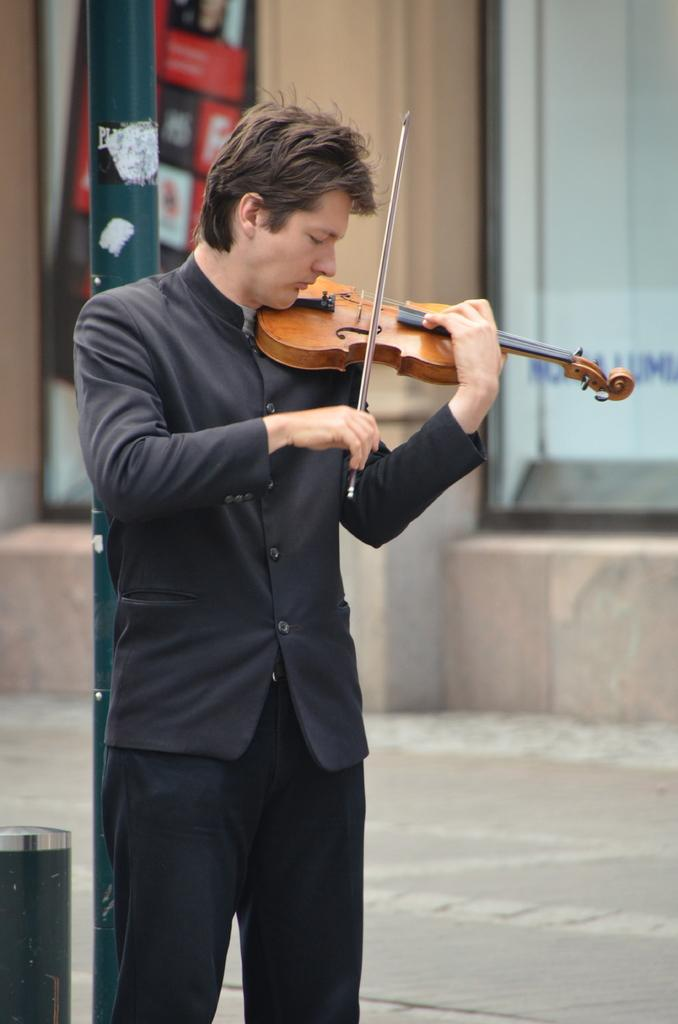What is the main subject of the image? There is a person in the image. What is the person doing in the image? The person is standing and playing a guitar. What type of behavior is the earth exhibiting in the image? There is no reference to the earth or any behavior in the image; it features a person standing and playing a guitar. 